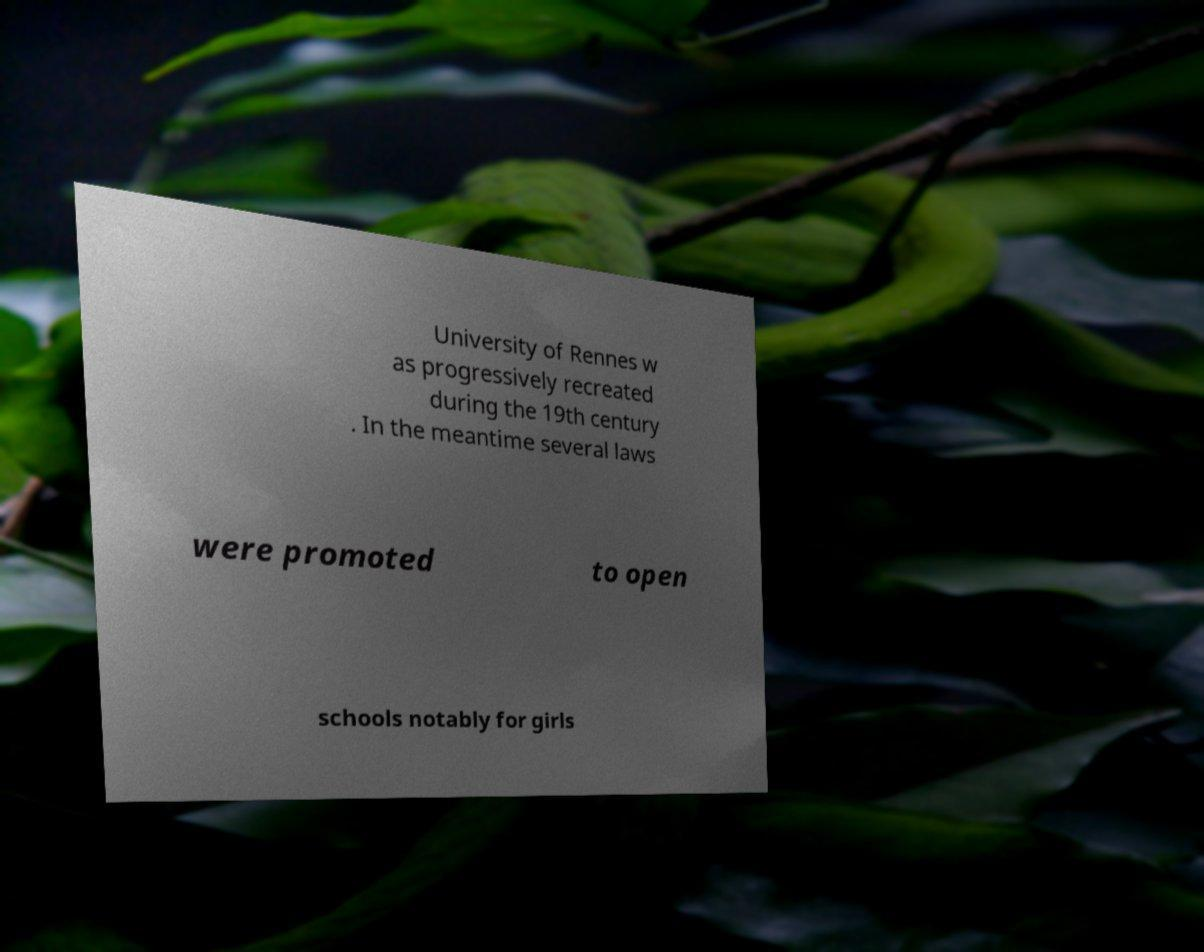Can you read and provide the text displayed in the image?This photo seems to have some interesting text. Can you extract and type it out for me? University of Rennes w as progressively recreated during the 19th century . In the meantime several laws were promoted to open schools notably for girls 